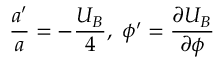Convert formula to latex. <formula><loc_0><loc_0><loc_500><loc_500>\frac { a ^ { \prime } } { a } = - \frac { U _ { B } } { 4 } , \ \phi ^ { \prime } = \frac { \partial U _ { B } } { \partial \phi }</formula> 